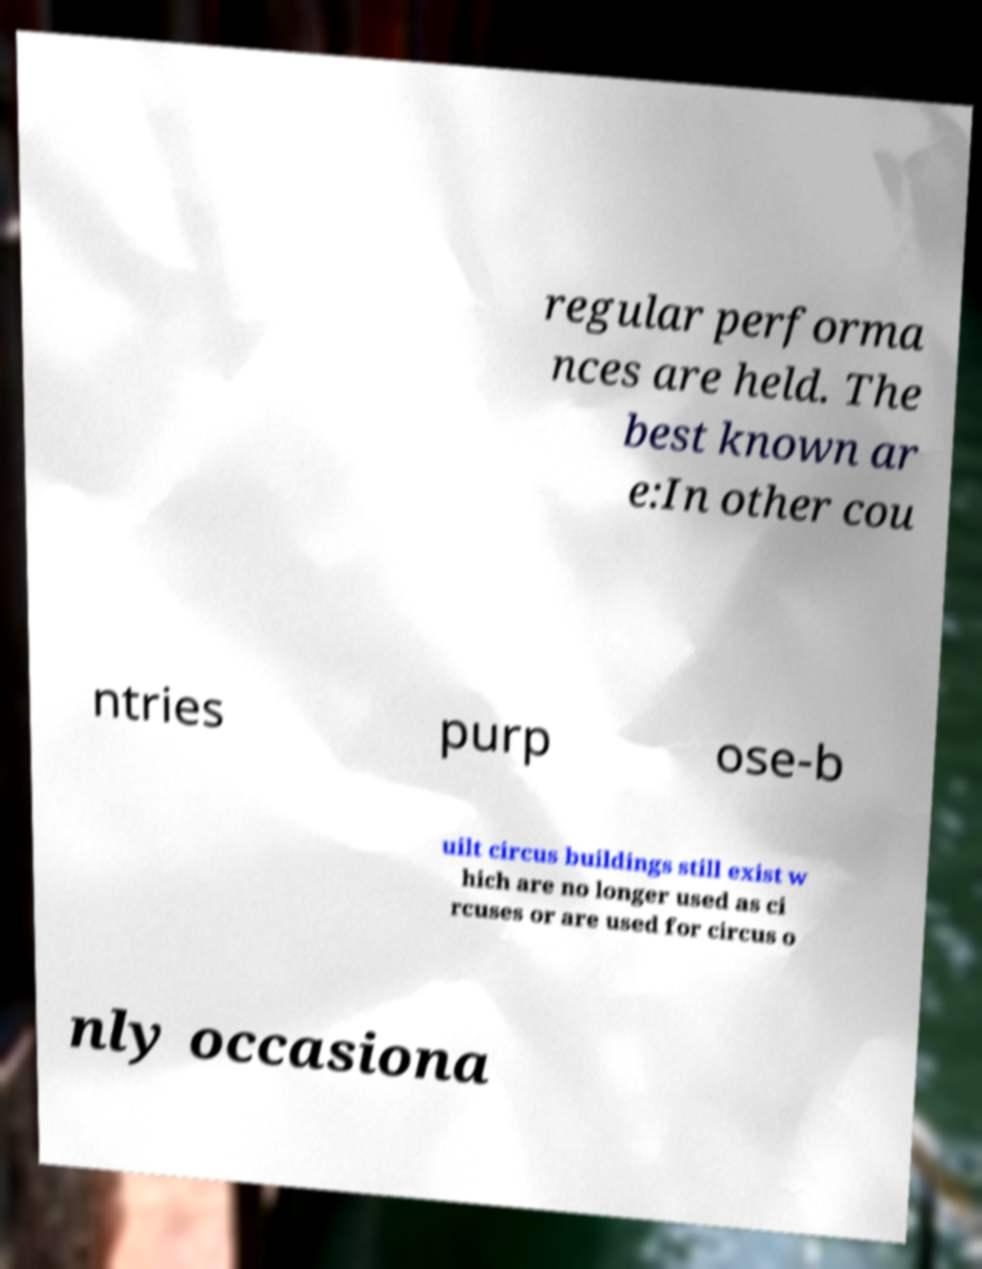Could you assist in decoding the text presented in this image and type it out clearly? regular performa nces are held. The best known ar e:In other cou ntries purp ose-b uilt circus buildings still exist w hich are no longer used as ci rcuses or are used for circus o nly occasiona 